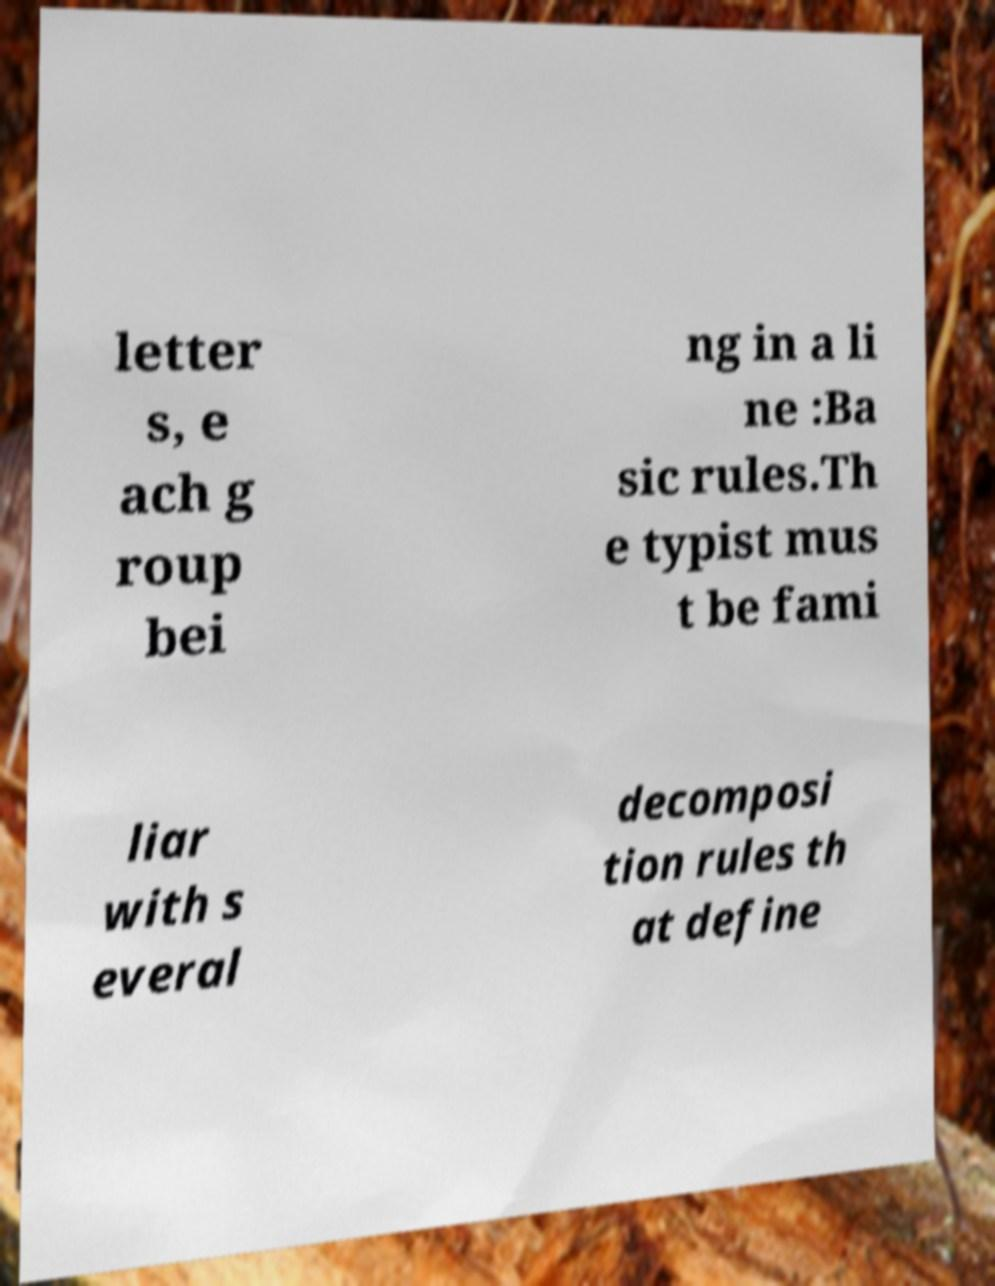For documentation purposes, I need the text within this image transcribed. Could you provide that? letter s, e ach g roup bei ng in a li ne :Ba sic rules.Th e typist mus t be fami liar with s everal decomposi tion rules th at define 